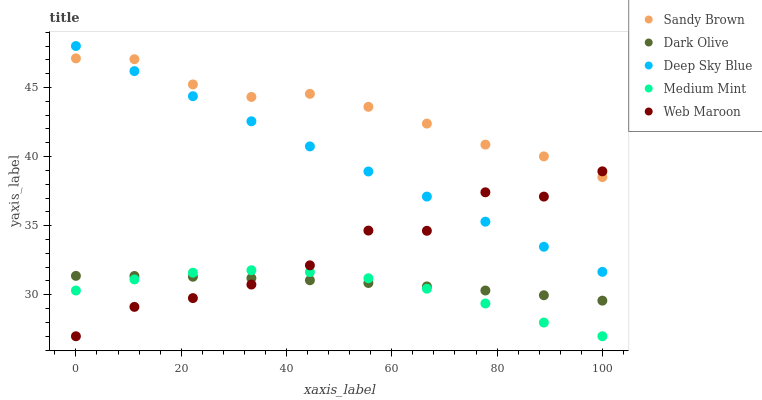Does Medium Mint have the minimum area under the curve?
Answer yes or no. Yes. Does Sandy Brown have the maximum area under the curve?
Answer yes or no. Yes. Does Web Maroon have the minimum area under the curve?
Answer yes or no. No. Does Web Maroon have the maximum area under the curve?
Answer yes or no. No. Is Deep Sky Blue the smoothest?
Answer yes or no. Yes. Is Web Maroon the roughest?
Answer yes or no. Yes. Is Dark Olive the smoothest?
Answer yes or no. No. Is Dark Olive the roughest?
Answer yes or no. No. Does Medium Mint have the lowest value?
Answer yes or no. Yes. Does Dark Olive have the lowest value?
Answer yes or no. No. Does Deep Sky Blue have the highest value?
Answer yes or no. Yes. Does Web Maroon have the highest value?
Answer yes or no. No. Is Medium Mint less than Sandy Brown?
Answer yes or no. Yes. Is Sandy Brown greater than Medium Mint?
Answer yes or no. Yes. Does Medium Mint intersect Dark Olive?
Answer yes or no. Yes. Is Medium Mint less than Dark Olive?
Answer yes or no. No. Is Medium Mint greater than Dark Olive?
Answer yes or no. No. Does Medium Mint intersect Sandy Brown?
Answer yes or no. No. 